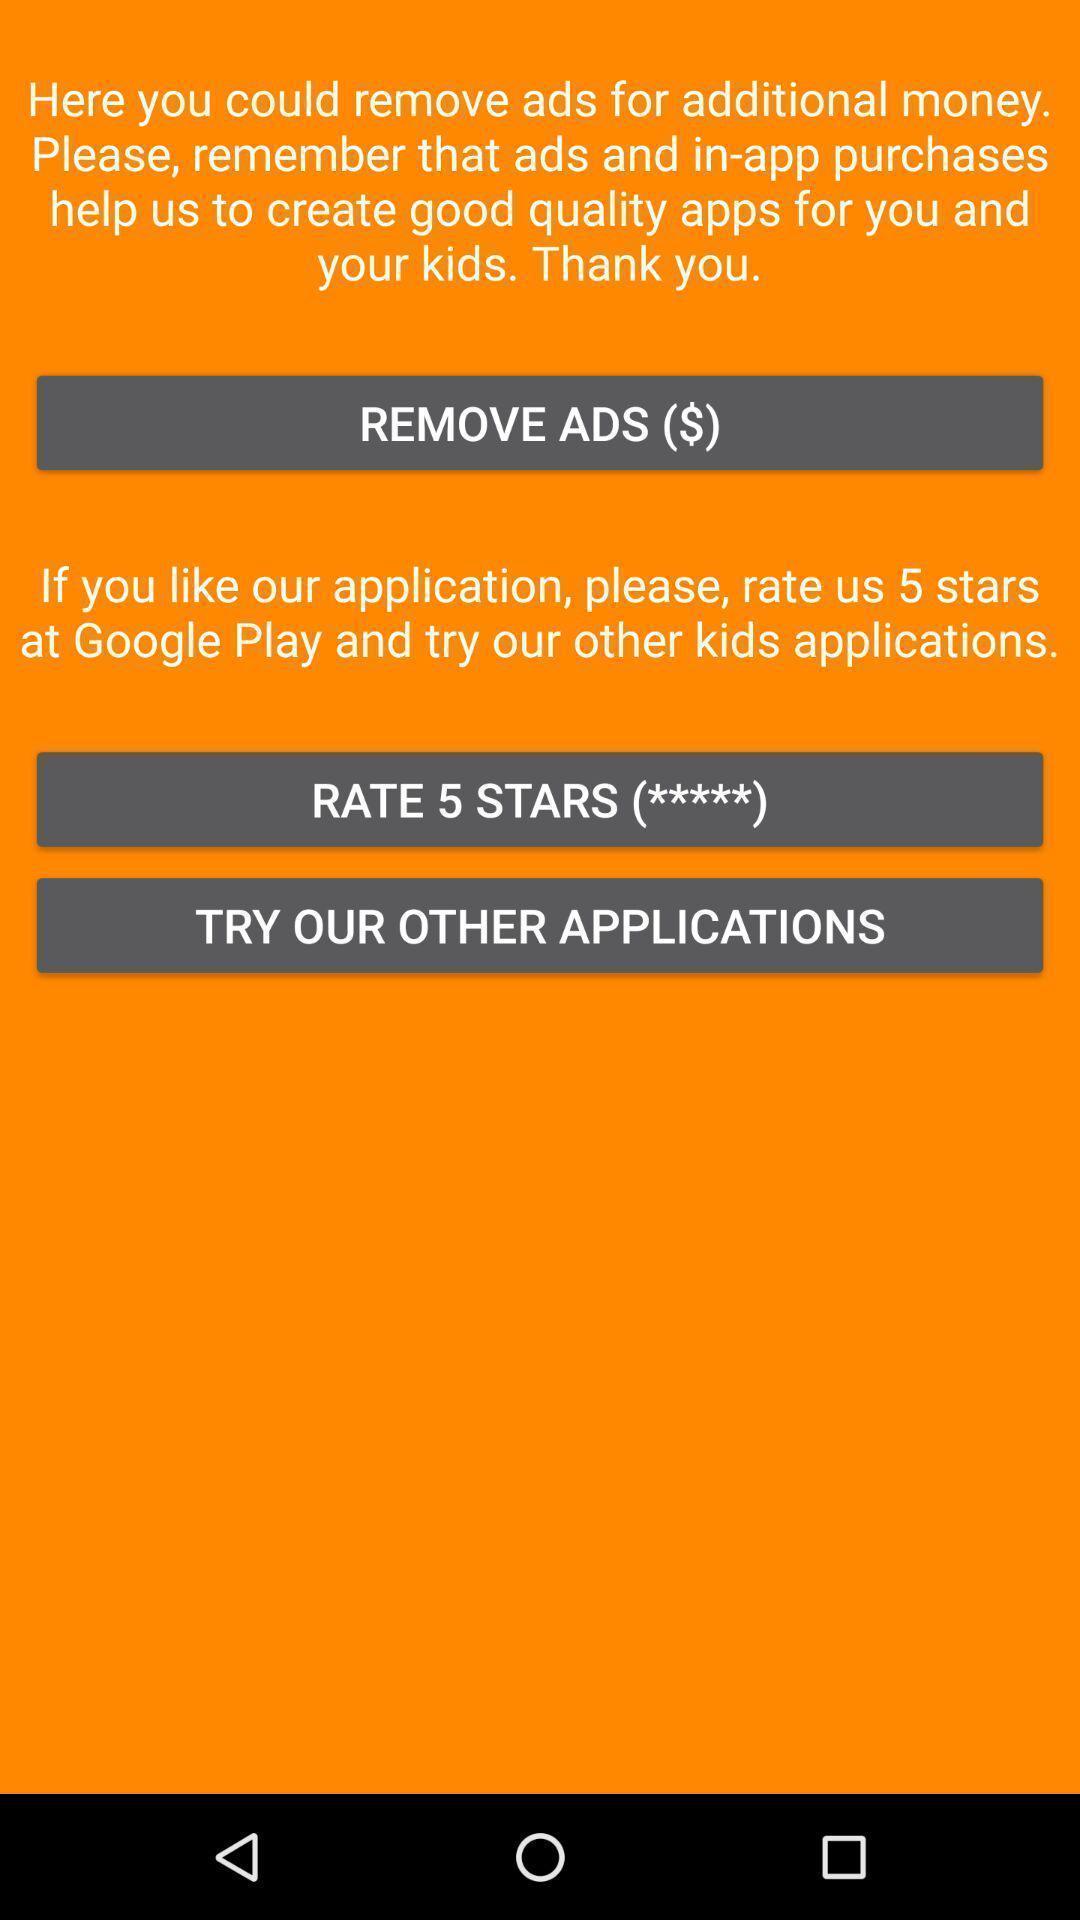Tell me about the visual elements in this screen capture. Screen asking to remove ads. Please provide a description for this image. Page showing some content and multiple options. 